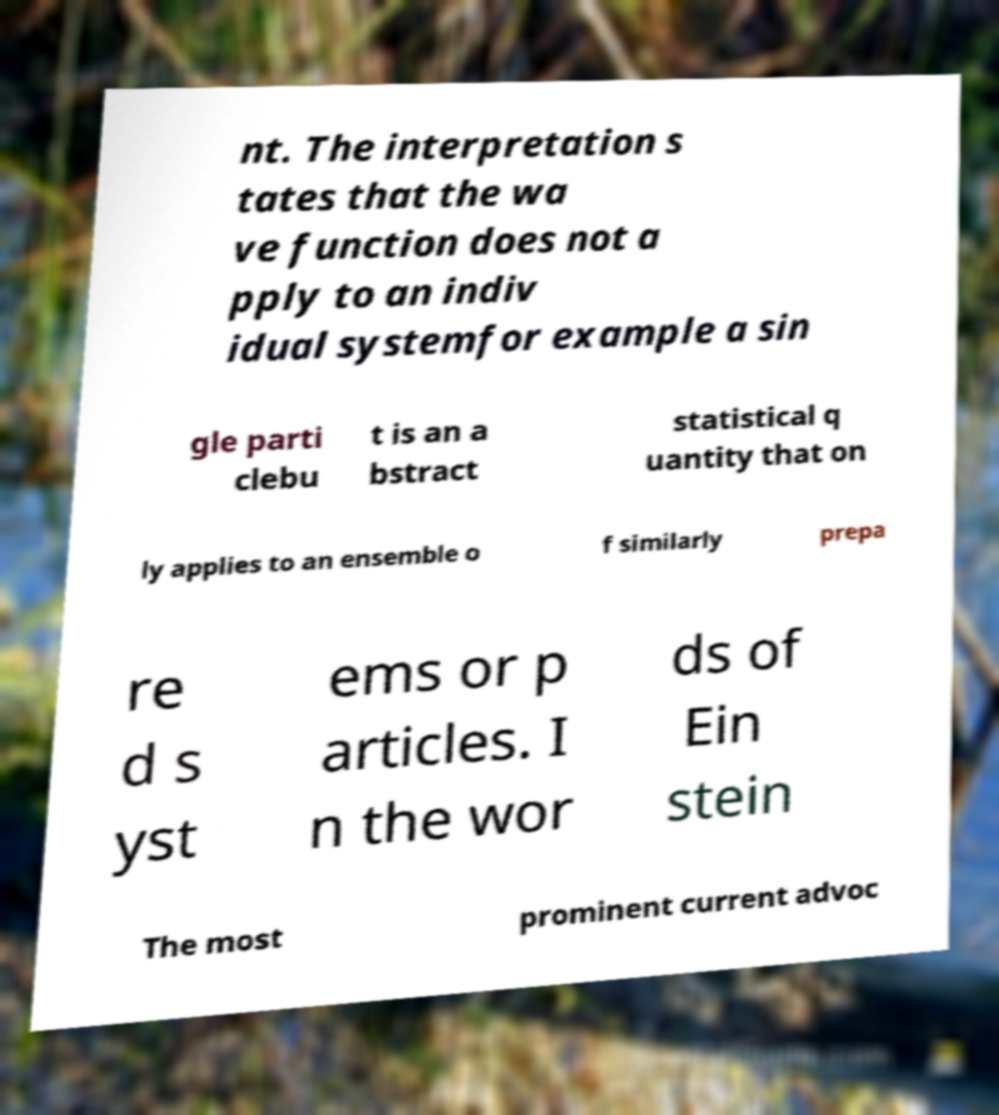Please read and relay the text visible in this image. What does it say? nt. The interpretation s tates that the wa ve function does not a pply to an indiv idual systemfor example a sin gle parti clebu t is an a bstract statistical q uantity that on ly applies to an ensemble o f similarly prepa re d s yst ems or p articles. I n the wor ds of Ein stein The most prominent current advoc 